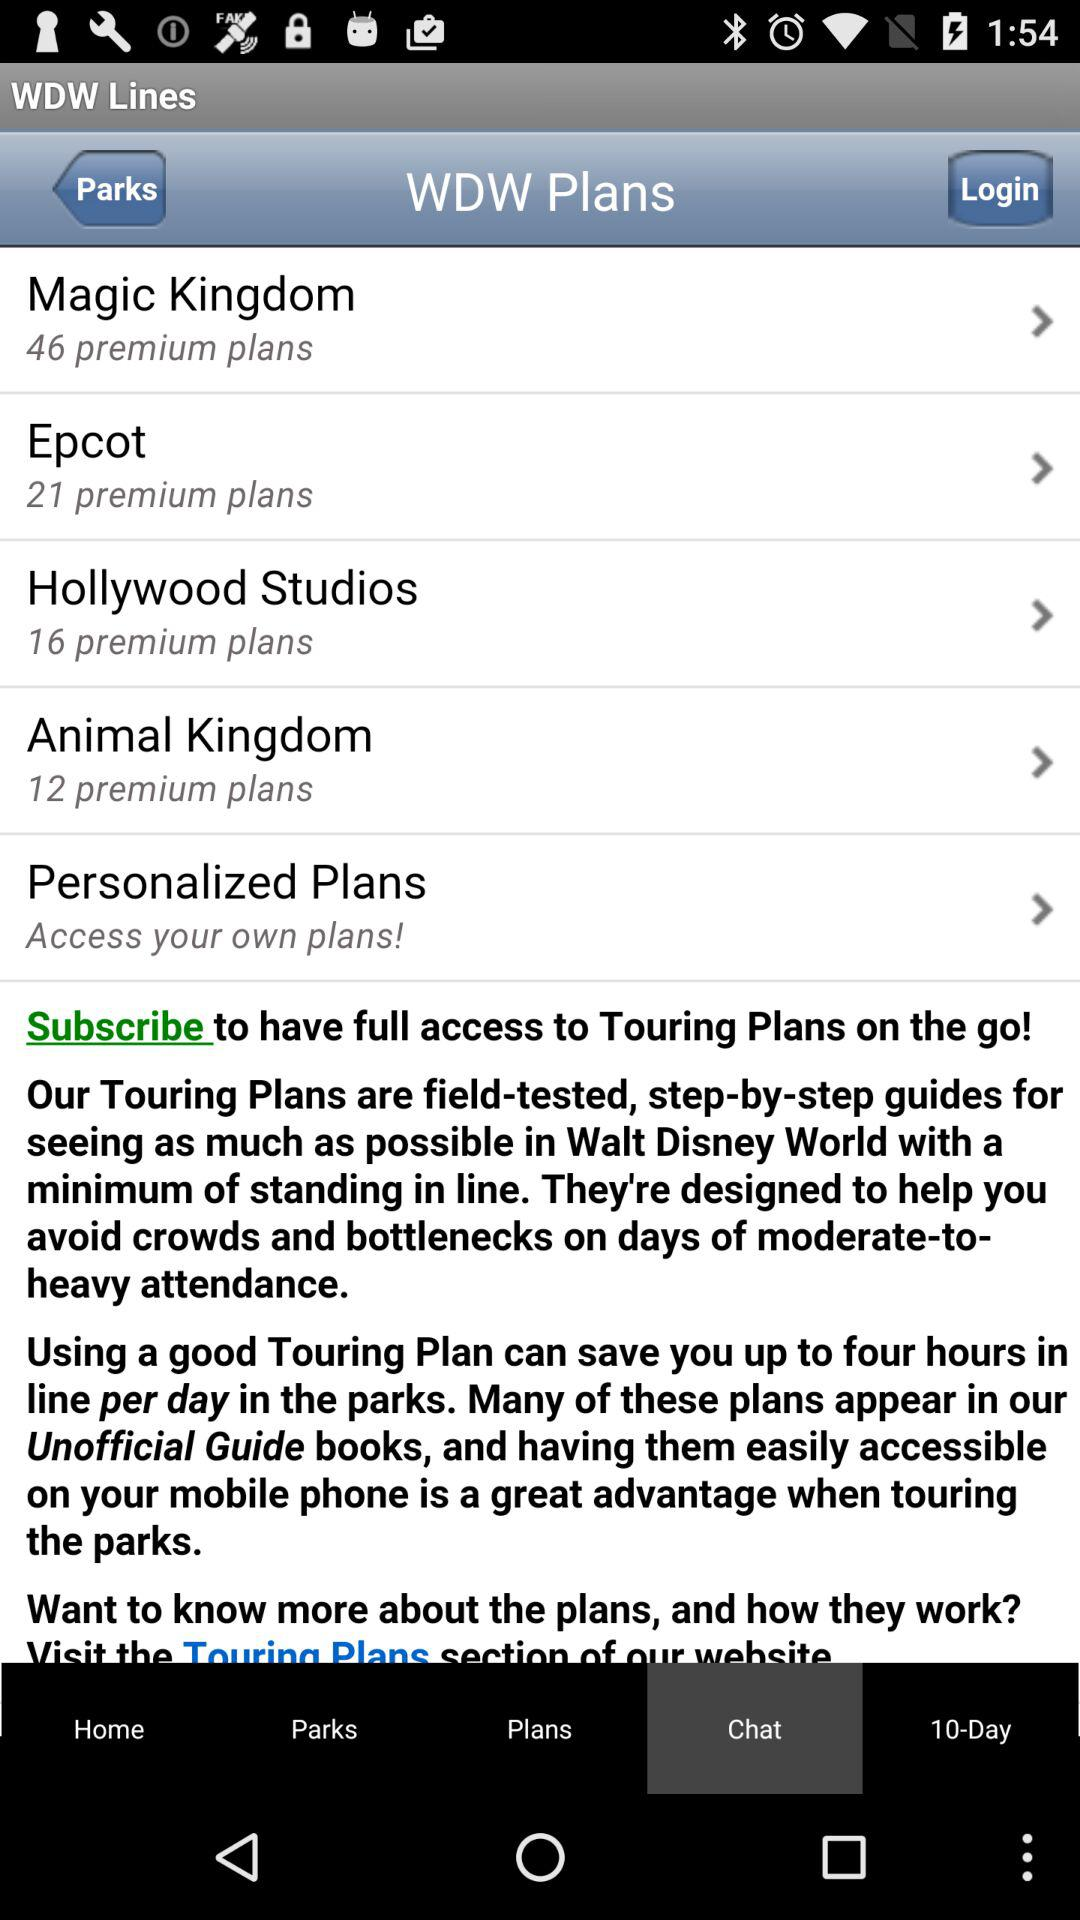How many plans are there in the "Magic Kingdom"? There are 46 plans in the "Magic Kingdom". 